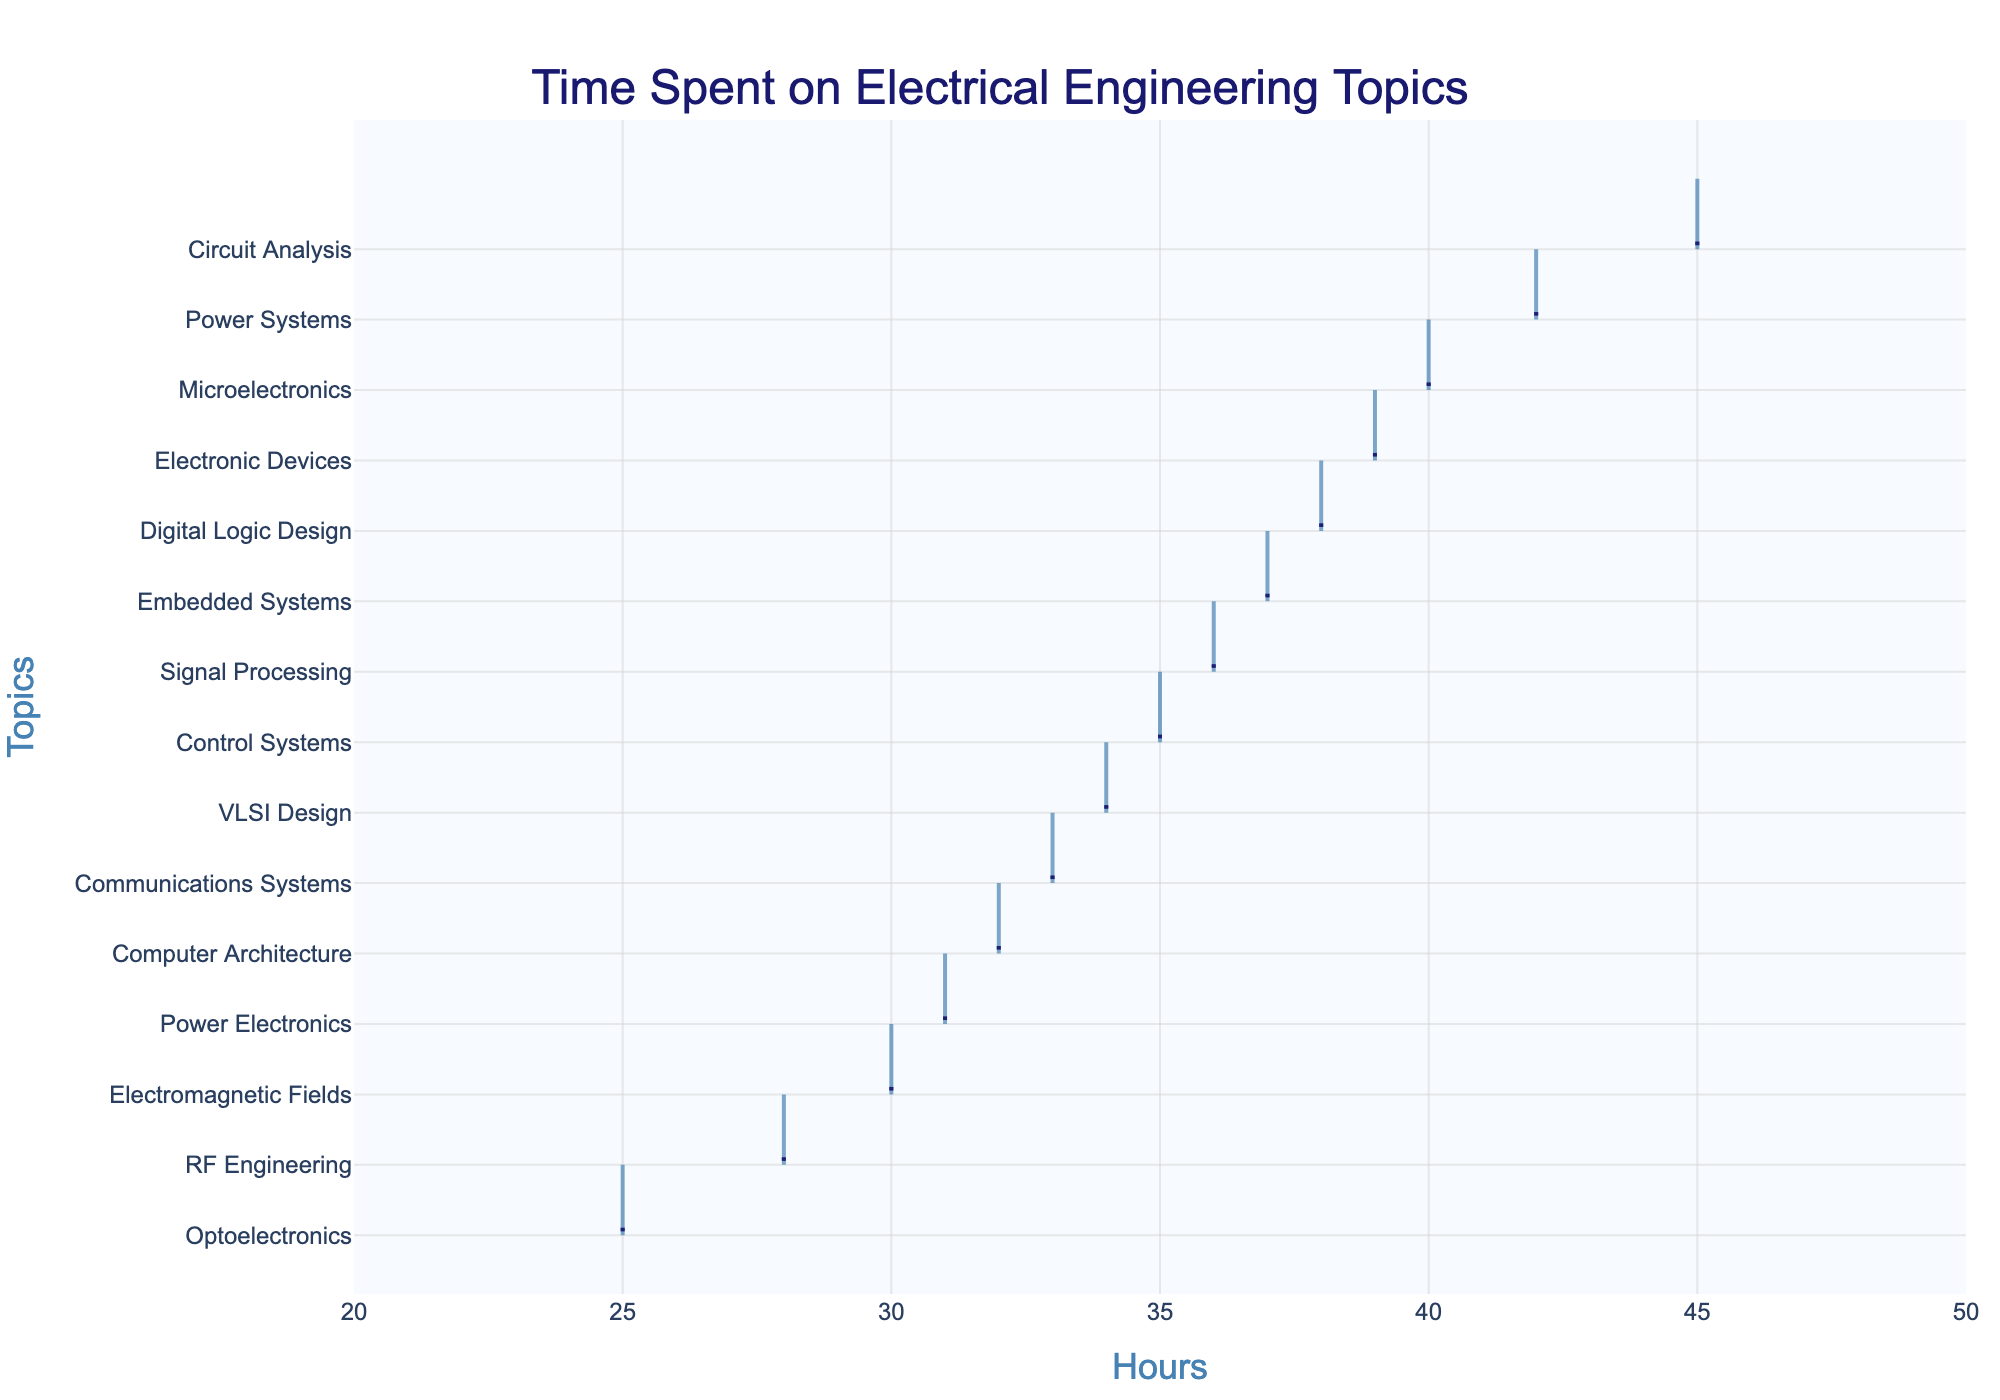What is the title of the figure? The title of the figure is clearly displayed at the top.
Answer: Time Spent on Electrical Engineering Topics How many different topics are shown on the y-axis? Count the number of unique topics listed on the y-axis.
Answer: 15 Which topic has the highest number of hours spent? Identify the box plot with the highest value on the x-axis.
Answer: Circuit Analysis Which topic has the lowest number of hours spent? Identify the box plot with the lowest value on the x-axis.
Answer: Optoelectronics What is the range of hours spent on topics, according to the x-axis? Look at the x-axis range labels to determine the minimum and maximum values.
Answer: 20 to 50 hours On which topics did students spend 35 or more hours? Look for topics where the box plot starts at or above the 35-hour mark on the x-axis.
Answer: Circuit Analysis, Digital Logic Design, Power Systems, Microelectronics, Electronic Devices, Embedded Systems, Signal Processing How does the time spent on Electronic Devices compare to Embedded Systems? Find the box plot positions of both topics and compare their values on the x-axis.
Answer: Electronic Devices have more hours than Embedded Systems What is the average of the hours spent on Power Systems and Control Systems? Add the hours of Power Systems and Control Systems and divide by 2. (42 + 35) / 2 = 38.5
Answer: 38.5 Are there more topics where students spent more than 30 hours or fewer than 30 hours? Count the number of topics above and below the 30-hour mark on the x-axis.
Answer: More topics where students spent more than 30 hours What type of plot is used to display the data? Identify the unique visual characteristics of the plot.
Answer: Horizontal density plot 